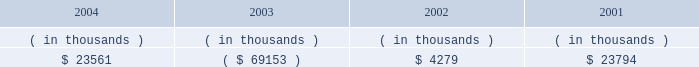Entergy arkansas , inc .
Management's financial discussion and analysis operating activities cash flow from operations increased $ 8.8 million in 2004 compared to 2003 primarily due to income tax benefits received in 2004 , and increased recovery of deferred fuel costs .
This increase was substantially offset by money pool activity .
In 2003 , the domestic utility companies and system energy filed , with the irs , a change in tax accounting method notification for their respective calculations of cost of goods sold .
The adjustment implemented a simplified method of allocation of overhead to the production of electricity , which is provided under the irs capitalization regulations .
The cumulative adjustment placing these companies on the new methodology resulted in a $ 1.171 billion deduction for entergy arkansas on entergy's 2003 income tax return .
There was no cash benefit from the method change in 2003 .
In 2004 , entergy arkansas realized $ 173 million in cash tax benefit from the method change .
This tax accounting method change is an issue across the utility industry and will likely be challenged by the irs on audit .
As of december 31 , 2004 , entergy arkansas has a net operating loss ( nol ) carryforward for tax purposes of $ 766.9 million , principally resulting from the change in tax accounting method related to cost of goods sold .
If the tax accounting method change is sustained , entergy arkansas expects to utilize the nol carryforward through 2006 .
Cash flow from operations increased $ 80.1 million in 2003 compared to 2002 primarily due to income taxes paid of $ 2.2 million in 2003 compared to income taxes paid of $ 83.9 million in 2002 , and money pool activity .
This increase was partially offset by decreased recovery of deferred fuel costs in 2003 .
Entergy arkansas' receivables from or ( payables to ) the money pool were as follows as of december 31 for each of the following years: .
Money pool activity used $ 92.7 million of entergy arkansas' operating cash flow in 2004 , provided $ 73.4 million in 2003 , and provided $ 19.5 million in 2002 .
See note 4 to the domestic utility companies and system energy financial statements for a description of the money pool .
Investing activities the decrease of $ 68.1 million in net cash used in investing activities in 2004 compared to 2003 was primarily due to a decrease in construction expenditures resulting from less transmission upgrade work requested by merchant generators in 2004 combined with lower spending on customer support projects in 2004 .
The increase of $ 88.1 million in net cash used in investing activities in 2003 compared to 2002 was primarily due to an increase in construction expenditures of $ 57.4 million and the maturity of $ 38.4 million of other temporary investments in the first quarter of 2002 .
Construction expenditures increased in 2003 primarily due to the following : 2022 a ferc ruling that shifted responsibility for transmission upgrade work performed for independent power producers to entergy arkansas ; and 2022 the ano 1 steam generator , reactor vessel head , and transformer replacement project .
Financing activities the decrease of $ 90.7 million in net cash used in financing activities in 2004 compared to 2003 was primarily due to the net redemption of $ 2.4 million of long-term debt in 2004 compared to $ 109.3 million in 2003 , partially offset by the payment of $ 16.2 million more in common stock dividends during the same period. .
What is the net cash flow from money pool activity related to entergy arkansas in the last three years? 
Computations: ((92.7 * const_m1) / 19.5)
Answer: -4.75385. 